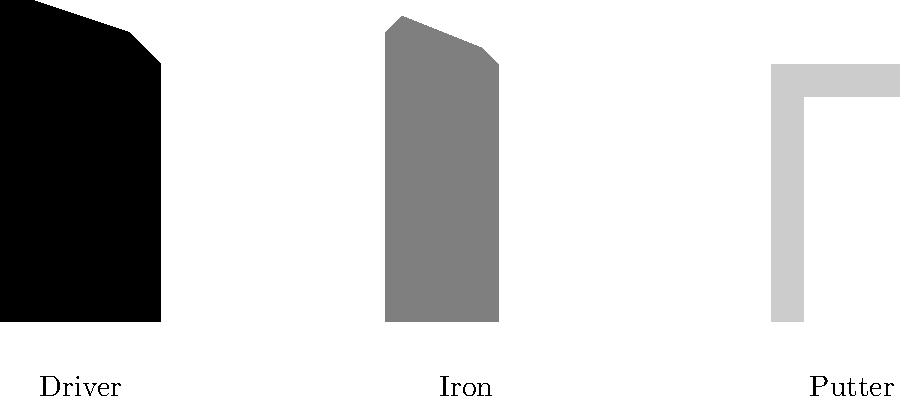Which silhouette represents the golf club typically used for long-distance shots off the tee? To identify the golf club used for long-distance shots off the tee, let's analyze the silhouettes:

1. The leftmost silhouette has a large, rounded head with a long shaft. This is characteristic of a driver, which is designed for maximum distance off the tee.

2. The middle silhouette has a smaller, angled head with a medium-length shaft. This represents an iron, used for approach shots and shorter distances.

3. The rightmost silhouette has a flat, rectangular head with a short shaft. This is a putter, used on the green for short, precise shots.

Given that we're looking for the club used for long-distance shots off the tee, the driver (leftmost silhouette) is the correct choice. Drivers are specifically designed with large heads to maximize the sweet spot and provide the most distance for tee shots on longer holes.
Answer: Driver 